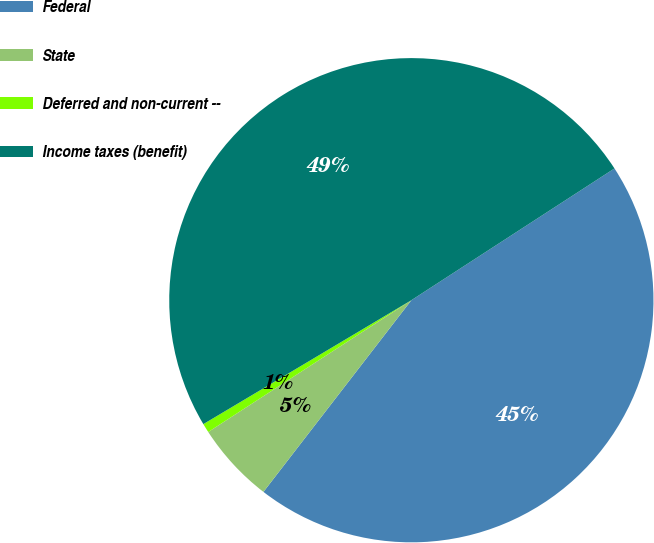Convert chart to OTSL. <chart><loc_0><loc_0><loc_500><loc_500><pie_chart><fcel>Federal<fcel>State<fcel>Deferred and non-current --<fcel>Income taxes (benefit)<nl><fcel>44.62%<fcel>5.38%<fcel>0.61%<fcel>49.39%<nl></chart> 